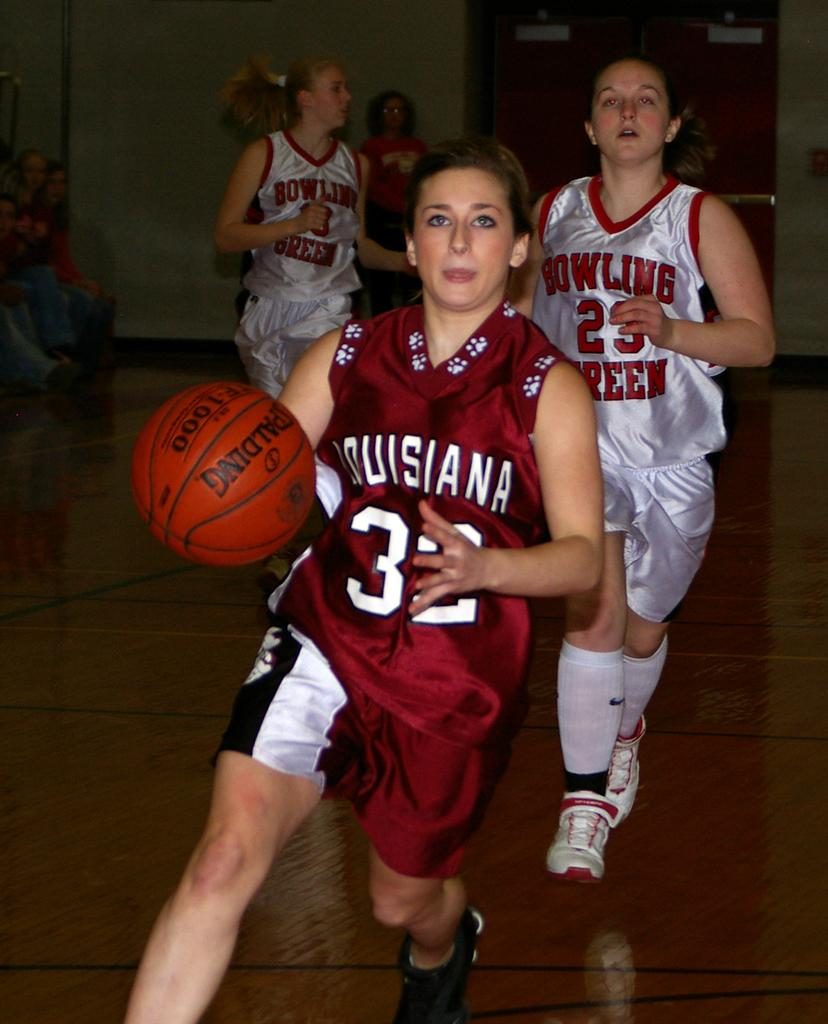<image>
Describe the image concisely. Bowling Green tries to get procession of the basketball from Louisiana. 